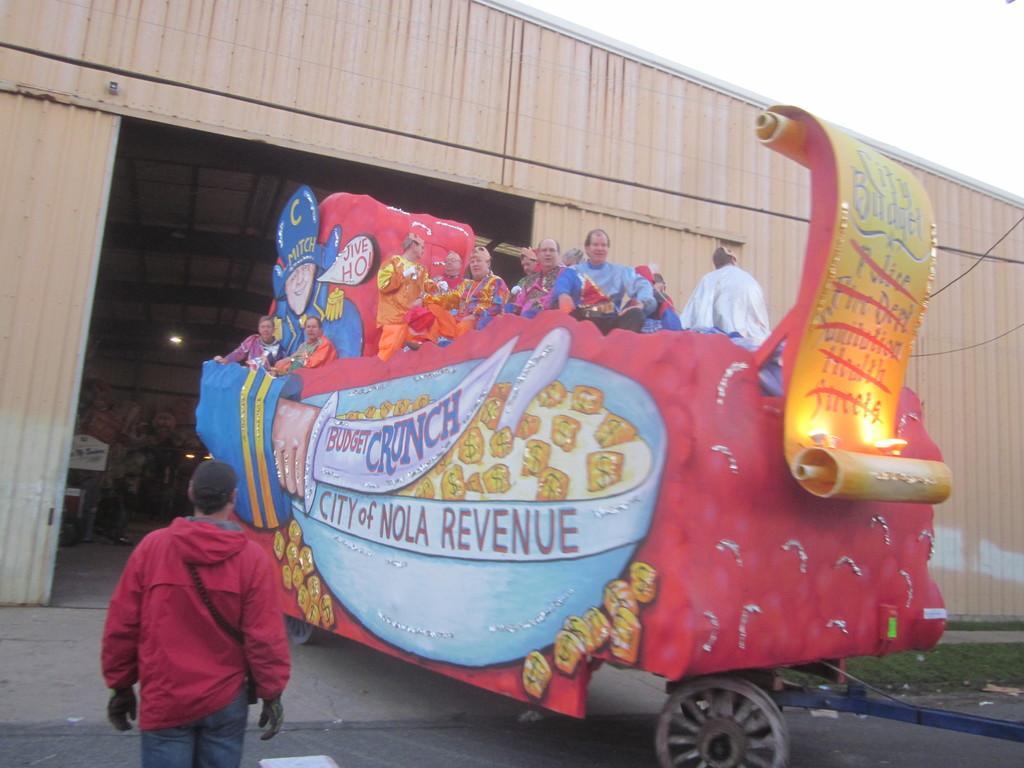Can you describe this image briefly? In this picture I can see group of people in a decorated vehicle, there are lights, a shed, a person standing , and in the background there is sky. 